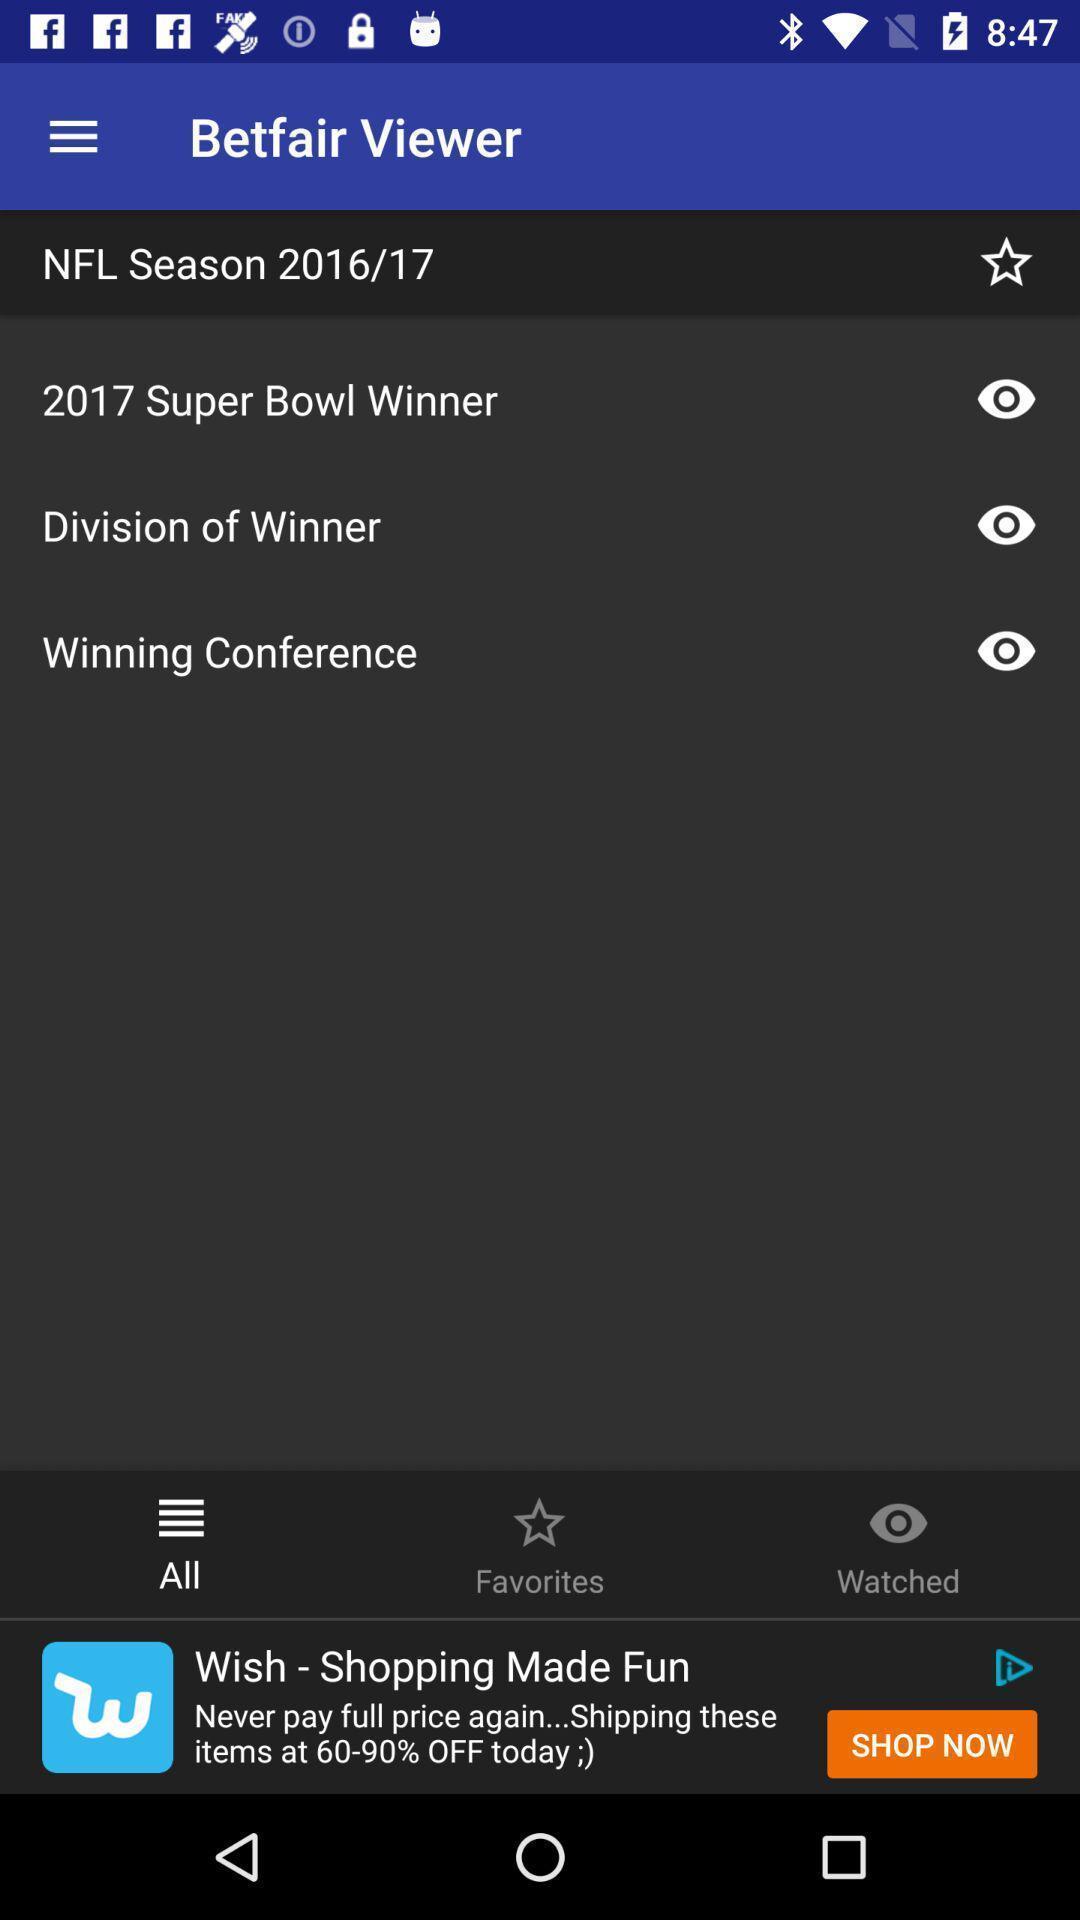Describe the visual elements of this screenshot. Page showing multiple options. 